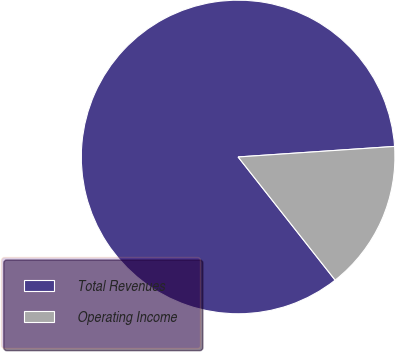Convert chart. <chart><loc_0><loc_0><loc_500><loc_500><pie_chart><fcel>Total Revenues<fcel>Operating Income<nl><fcel>84.55%<fcel>15.45%<nl></chart> 